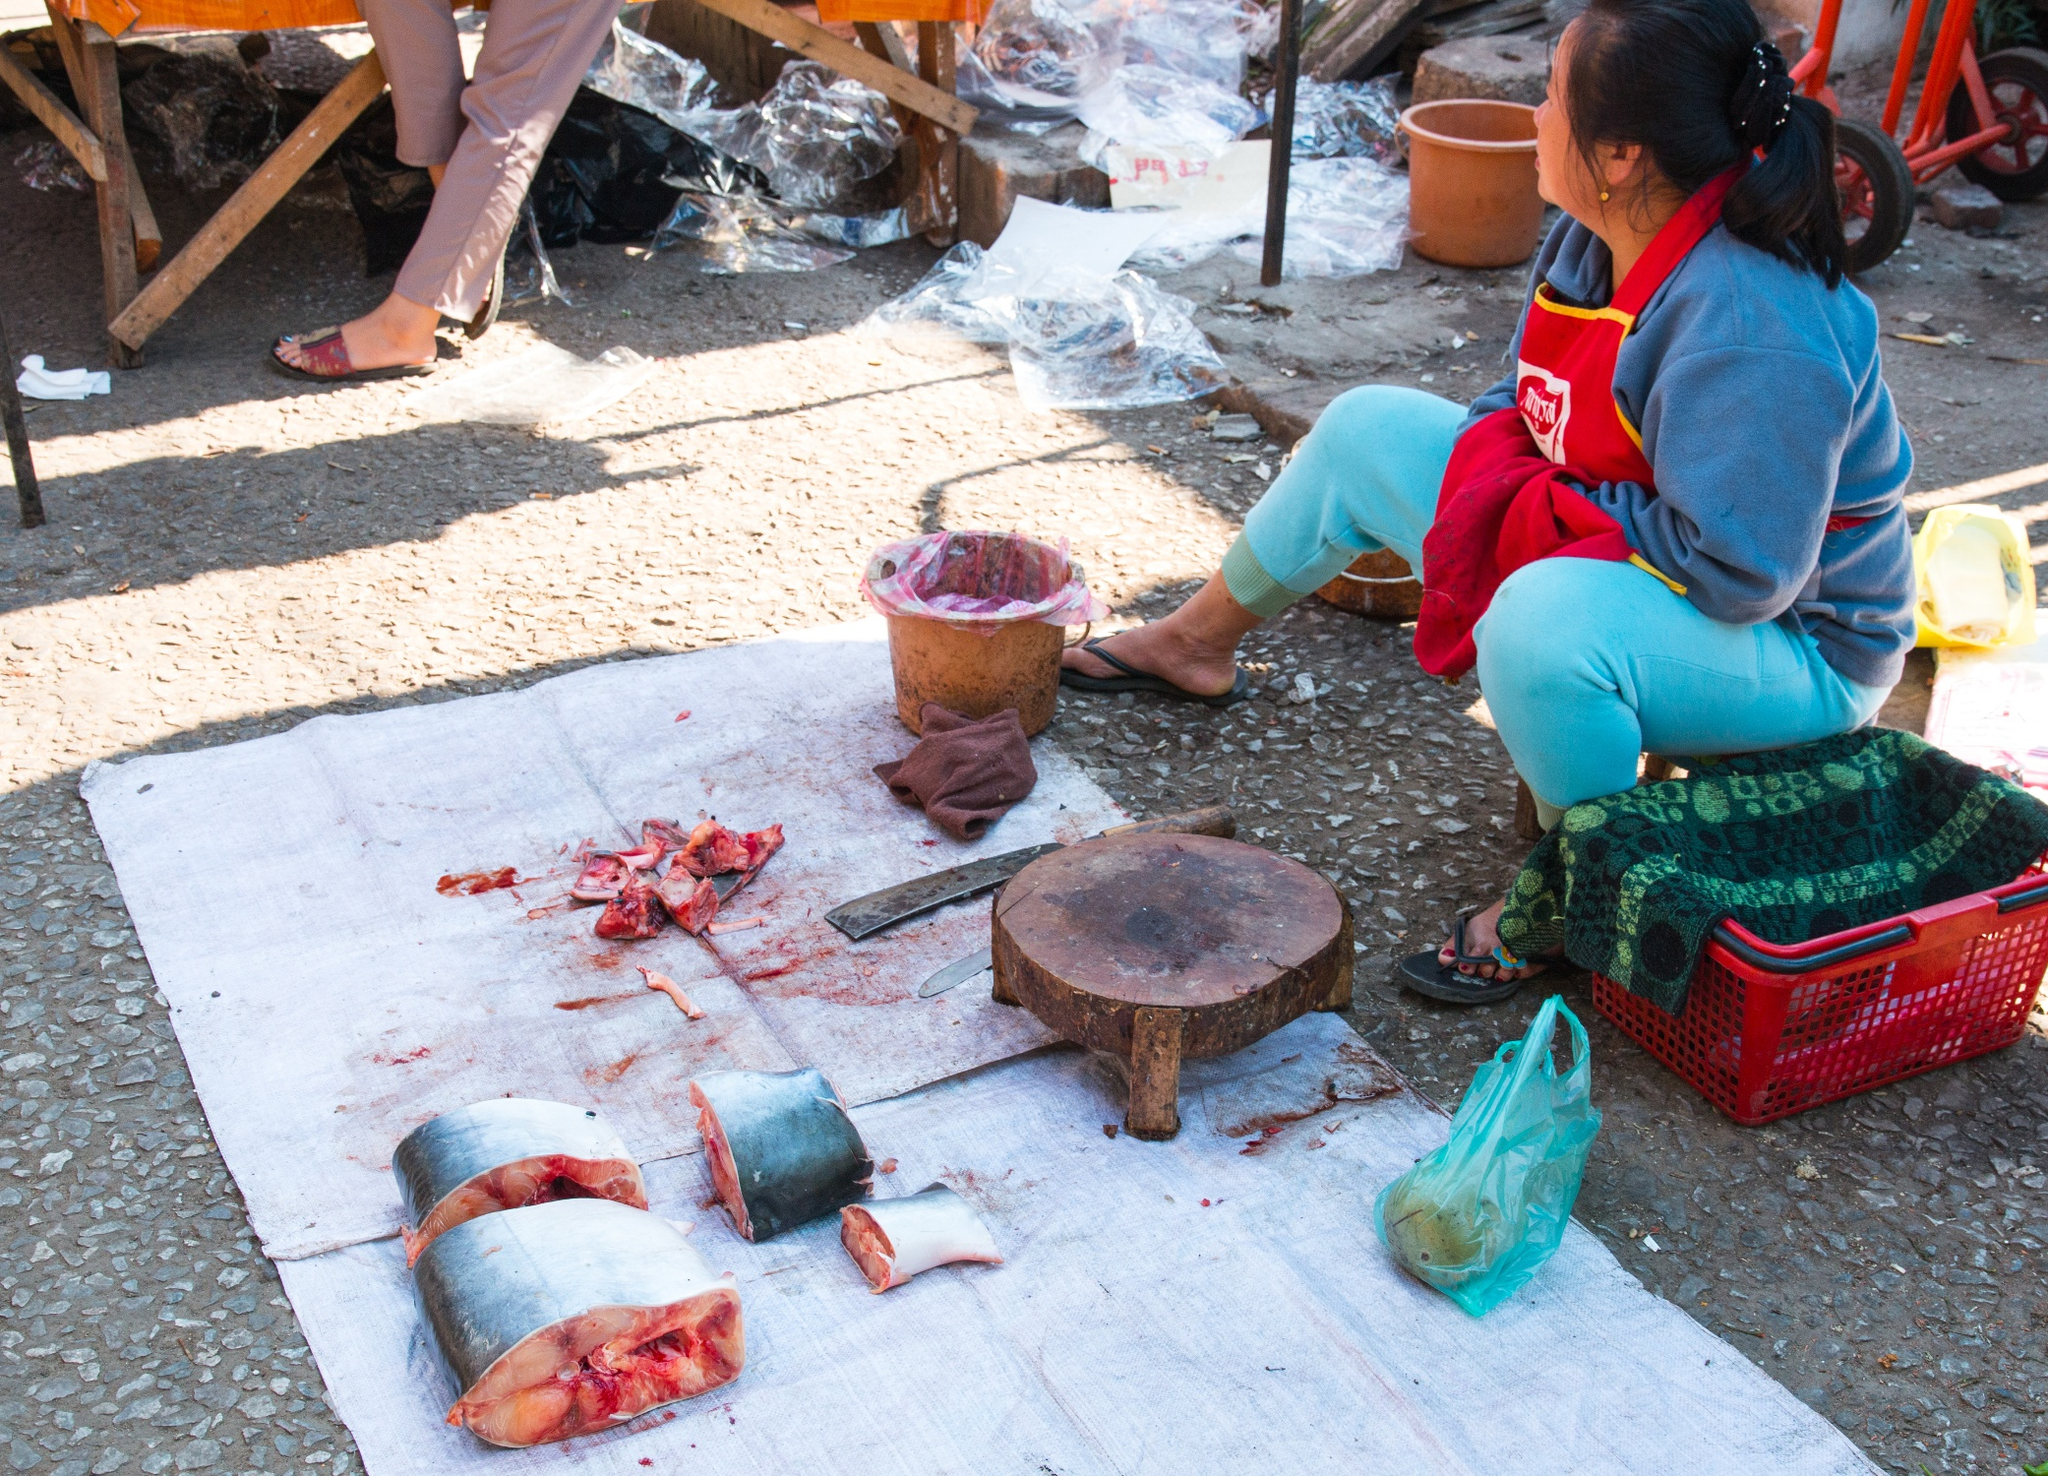Explain the visual content of the image in great detail. In the central part of this outdoor setting, a woman is sitting on a green plastic stool. Dressed in a warm and vibrant red sweater paired with blue pants, she focuses intently on her task of preparing fish. The scene is illuminated by natural light, highlighting her methodical movements as she works over a white tarp spread across a rough, pebbled ground.

The workspace is organized with various tools neatly laid out. Several cut pieces of fish are arranged on the tarp. A large knife, reflecting a clean, sharp edge, lies nearby. Adjacent to it are a couple of wooden chopping blocks, hinting at the intricate process of cutting and preparing the fish. Empty metal bowls are ready to hold the prepared fish pieces, indicating a systematic workflow.

Surrounding her are everyday objects scattered casually yet within convenient reach. A red plastic basket, a yellow plastic bag, and a green plastic bag might be holding additional supplies or tools. She appears to be using an orange plastic-lined container, possibly for waste or further preparation needs. A small, wooden stool is unoccupied and positioned slightly away from her.

The background reveals more about the setting: a rustic, wooden structure that encloses this area, likely part of a market or an outdoor kitchen. Despite the seemingly simple and utilitarian environment, the scene exudes a sense of dedication and purpose, as the woman diligently engages in her task of preparing fresh fish. 